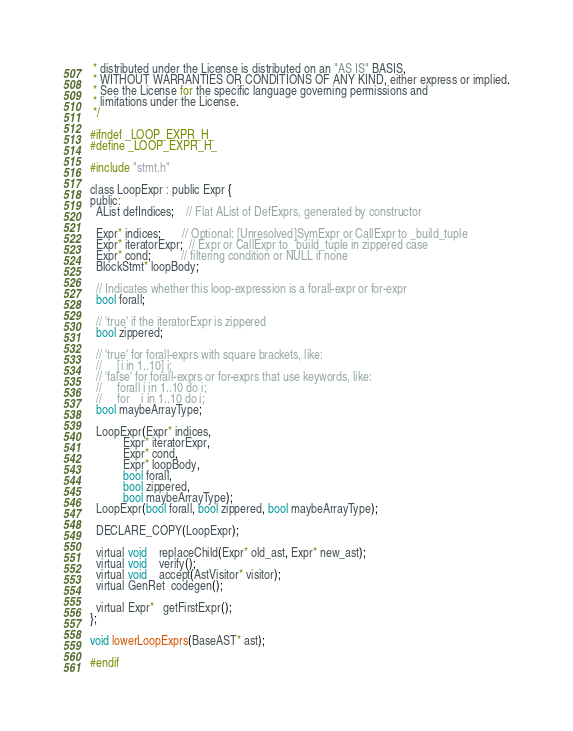<code> <loc_0><loc_0><loc_500><loc_500><_C_> * distributed under the License is distributed on an "AS IS" BASIS,
 * WITHOUT WARRANTIES OR CONDITIONS OF ANY KIND, either express or implied.
 * See the License for the specific language governing permissions and
 * limitations under the License.
 */

#ifndef _LOOP_EXPR_H_
#define _LOOP_EXPR_H_

#include "stmt.h"

class LoopExpr : public Expr {
public:
  AList defIndices;    // Flat AList of DefExprs, generated by constructor

  Expr* indices;       // Optional: [Unresolved]SymExpr or CallExpr to _build_tuple
  Expr* iteratorExpr;  // Expr or CallExpr to _build_tuple in zippered case
  Expr* cond;          // filtering condition or NULL if none
  BlockStmt* loopBody;

  // Indicates whether this loop-expression is a forall-expr or for-expr
  bool forall;

  // 'true' if the iteratorExpr is zippered
  bool zippered;

  // 'true' for forall-exprs with square brackets, like:
  //     [i in 1..10] i;
  // 'false' for forall-exprs or for-exprs that use keywords, like:
  //     forall i in 1..10 do i;
  //     for    i in 1..10 do i;
  bool maybeArrayType;

  LoopExpr(Expr* indices,
           Expr* iteratorExpr,
           Expr* cond,
           Expr* loopBody,
           bool forall,
           bool zippered,
           bool maybeArrayType);
  LoopExpr(bool forall, bool zippered, bool maybeArrayType);

  DECLARE_COPY(LoopExpr);

  virtual void    replaceChild(Expr* old_ast, Expr* new_ast);
  virtual void    verify();
  virtual void    accept(AstVisitor* visitor);
  virtual GenRet  codegen();

  virtual Expr*   getFirstExpr();
};

void lowerLoopExprs(BaseAST* ast);

#endif
</code> 